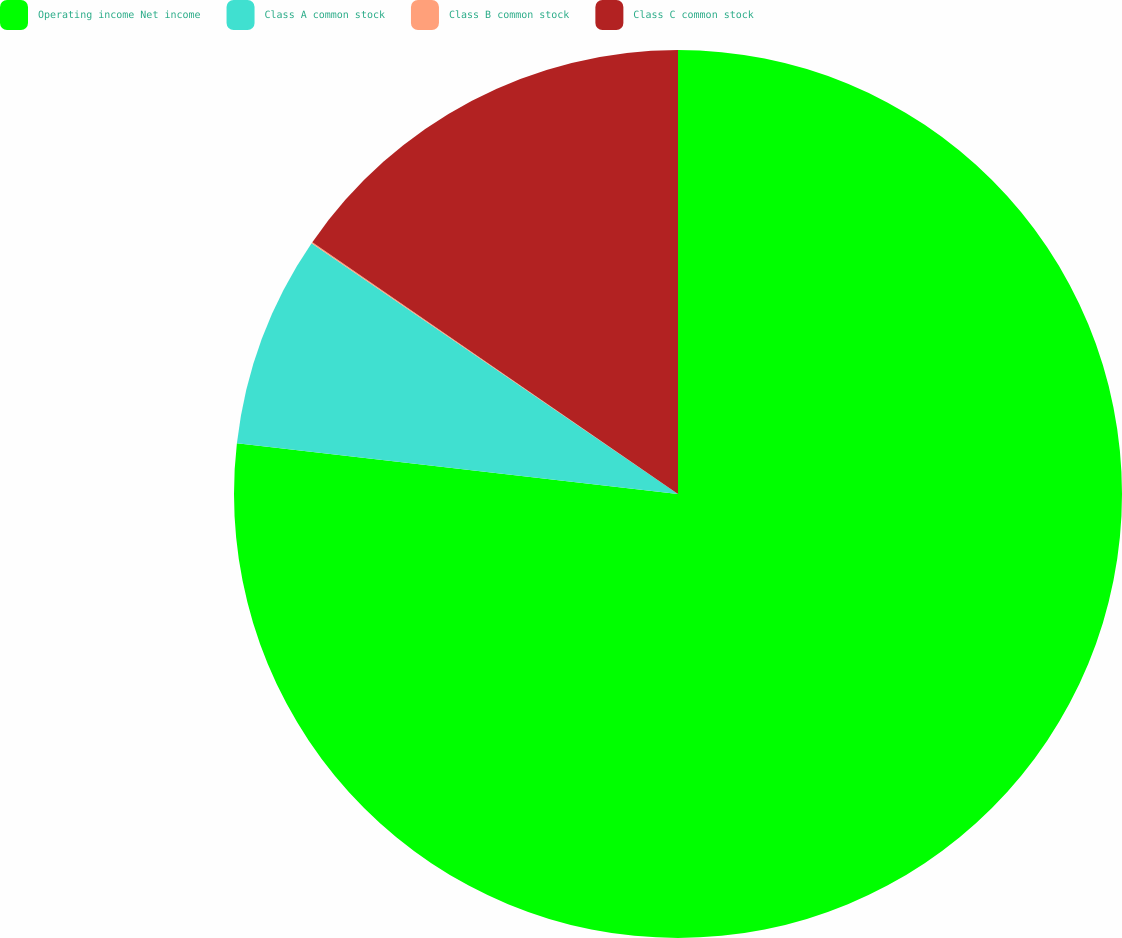Convert chart to OTSL. <chart><loc_0><loc_0><loc_500><loc_500><pie_chart><fcel>Operating income Net income<fcel>Class A common stock<fcel>Class B common stock<fcel>Class C common stock<nl><fcel>76.82%<fcel>7.73%<fcel>0.05%<fcel>15.4%<nl></chart> 